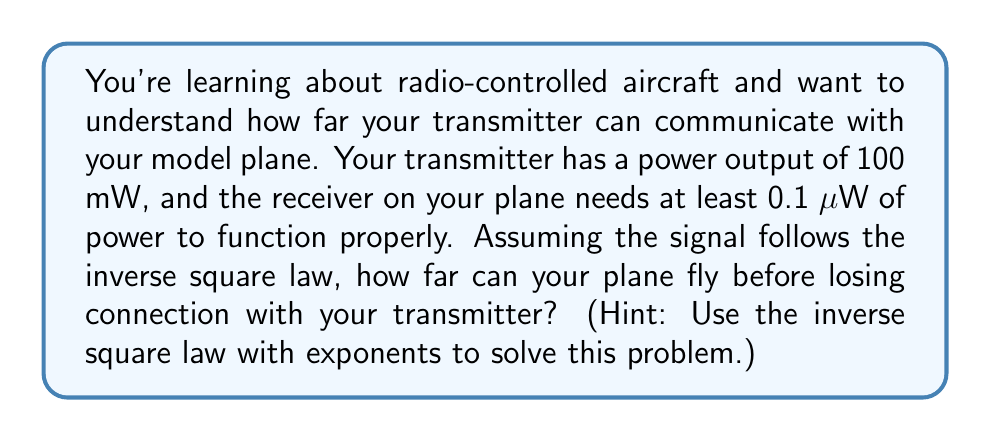Solve this math problem. Let's approach this step-by-step:

1) The inverse square law states that the power (P) of a signal is inversely proportional to the square of the distance (d) from the source. We can express this mathematically as:

   $P \propto \frac{1}{d^2}$

2) To turn this into an equation, we introduce a constant k:

   $P = \frac{k}{d^2}$

3) We know two things:
   - At the transmitter (d = 0), P = 100 mW
   - At the maximum range, P = 0.1 μW = 0.0000001 W

4) Let's use the transmitter information to find k:

   $100 \times 10^{-3} = \frac{k}{0^2}$

   $k = 100 \times 10^{-3} = 0.1$

5) Now we can set up our equation for the maximum range:

   $0.0000001 = \frac{0.1}{d^2}$

6) Solve for d:

   $d^2 = \frac{0.1}{0.0000001} = 1,000,000$

   $d = \sqrt{1,000,000} = 1,000$ meters

Therefore, the maximum range is 1,000 meters.
Answer: 1,000 meters 